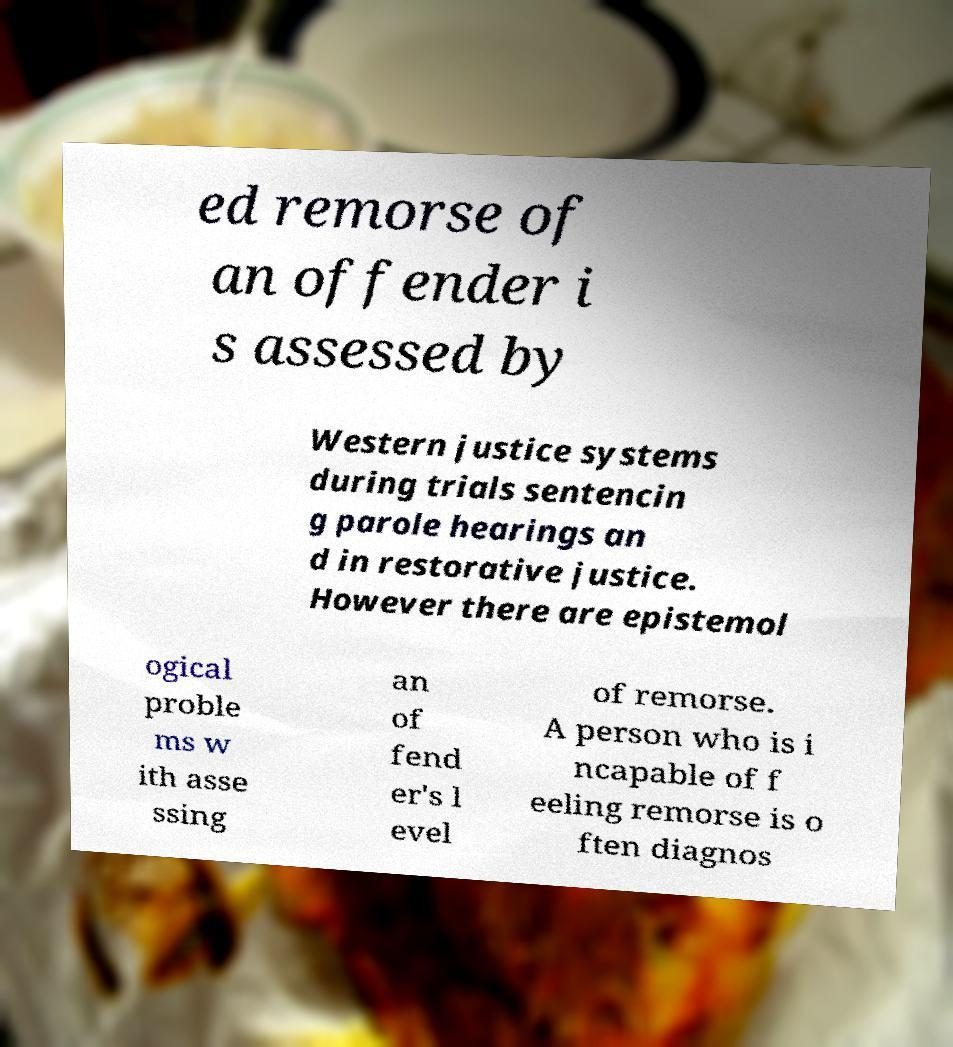What messages or text are displayed in this image? I need them in a readable, typed format. ed remorse of an offender i s assessed by Western justice systems during trials sentencin g parole hearings an d in restorative justice. However there are epistemol ogical proble ms w ith asse ssing an of fend er's l evel of remorse. A person who is i ncapable of f eeling remorse is o ften diagnos 